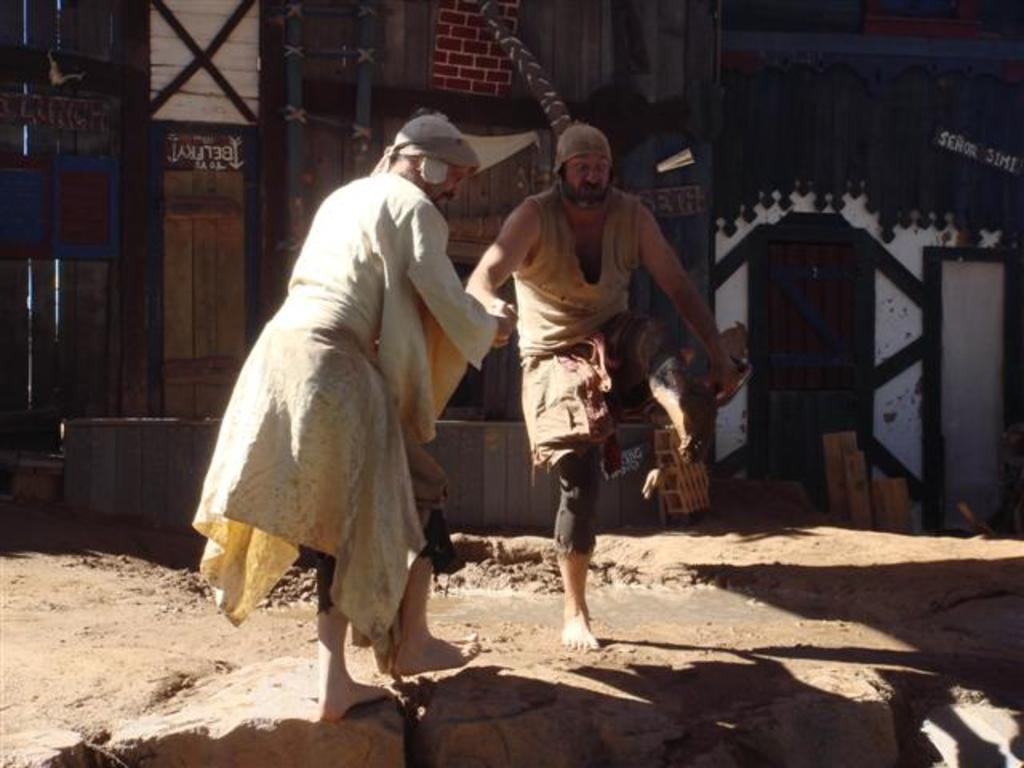What is happening in the center of the image? There are persons standing in the center of the image. What can be seen in the background of the image? There are doors and a white wall in the background of the image. What type of credit can be seen on the white wall in the image? There is no credit or any text visible on the white wall in the image. Can you tell me how many socks are hanging on the doors in the image? There are no socks present in the image; only doors and a white wall are visible in the background. 